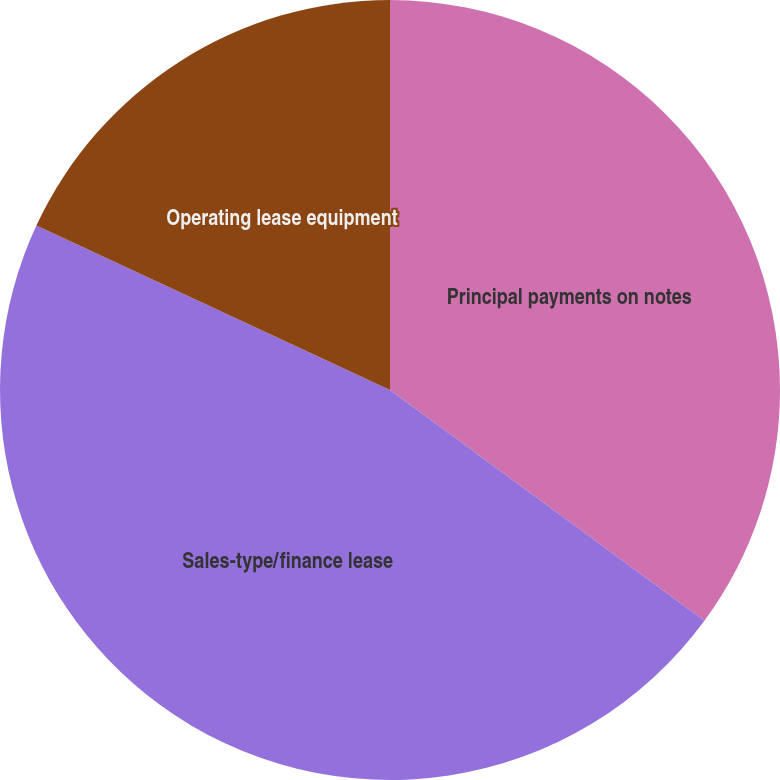Convert chart. <chart><loc_0><loc_0><loc_500><loc_500><pie_chart><fcel>Principal payments on notes<fcel>Sales-type/finance lease<fcel>Operating lease equipment<nl><fcel>35.08%<fcel>46.85%<fcel>18.07%<nl></chart> 